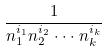Convert formula to latex. <formula><loc_0><loc_0><loc_500><loc_500>\frac { 1 } { n _ { 1 } ^ { i _ { 1 } } n _ { 2 } ^ { i _ { 2 } } \cdot \cdot \cdot n _ { k } ^ { i _ { k } } }</formula> 